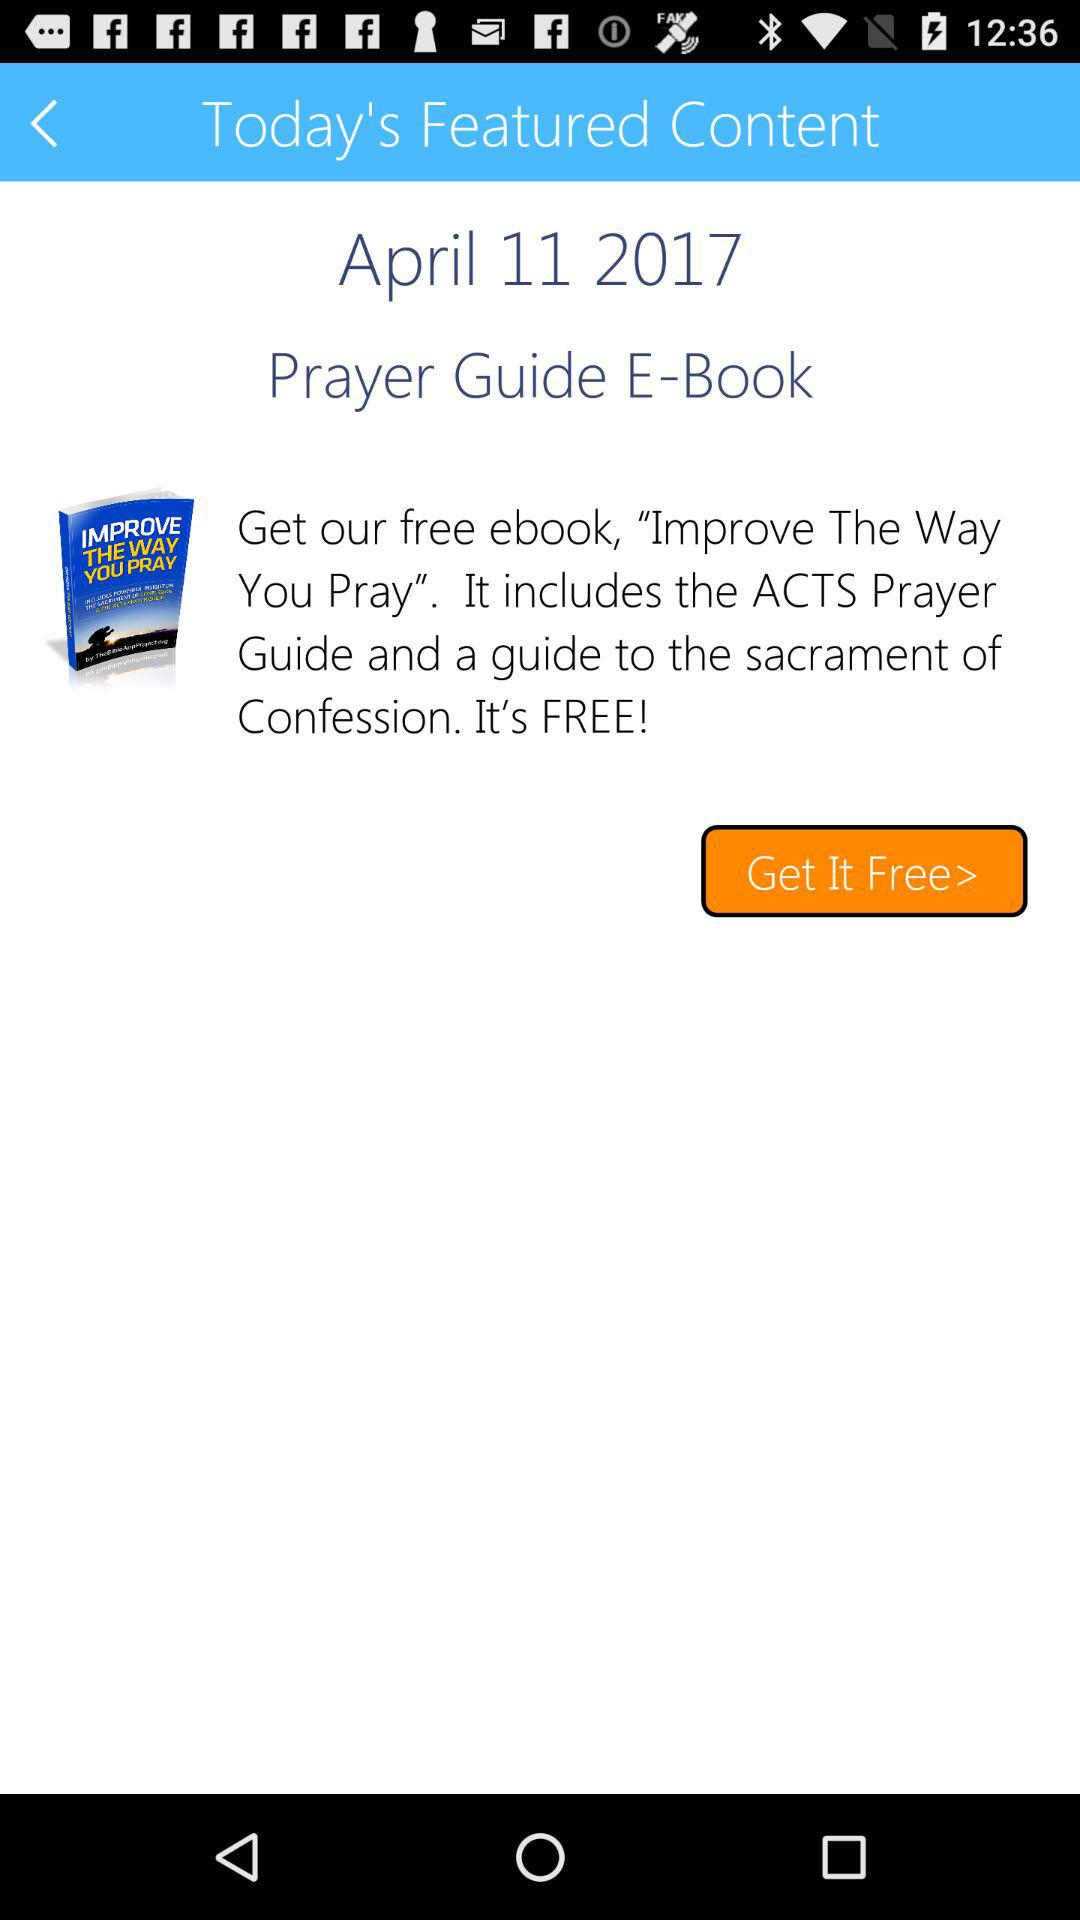What is the date shown on the screen? The date shown on the screen is April 11, 2017. 